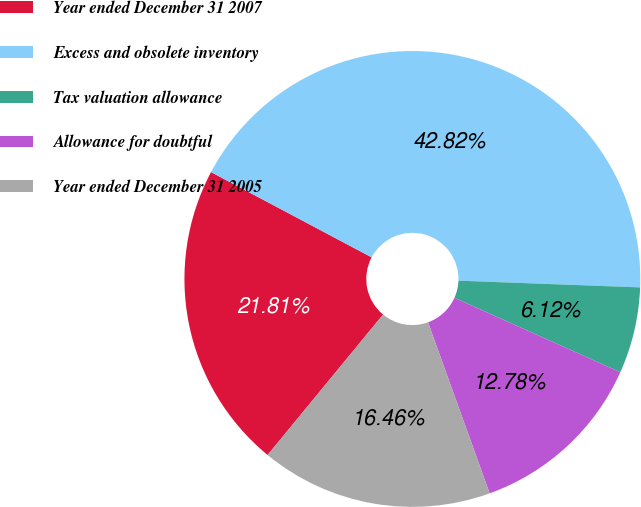Convert chart to OTSL. <chart><loc_0><loc_0><loc_500><loc_500><pie_chart><fcel>Year ended December 31 2007<fcel>Excess and obsolete inventory<fcel>Tax valuation allowance<fcel>Allowance for doubtful<fcel>Year ended December 31 2005<nl><fcel>21.81%<fcel>42.82%<fcel>6.12%<fcel>12.78%<fcel>16.46%<nl></chart> 